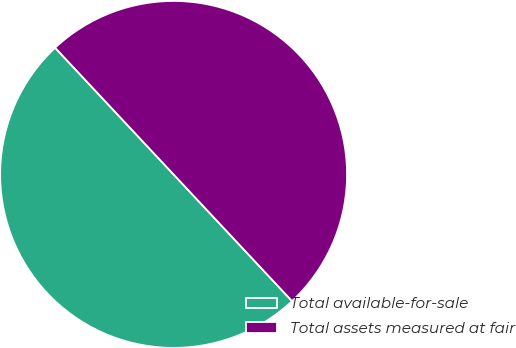Convert chart. <chart><loc_0><loc_0><loc_500><loc_500><pie_chart><fcel>Total available-for-sale<fcel>Total assets measured at fair<nl><fcel>50.0%<fcel>50.0%<nl></chart> 